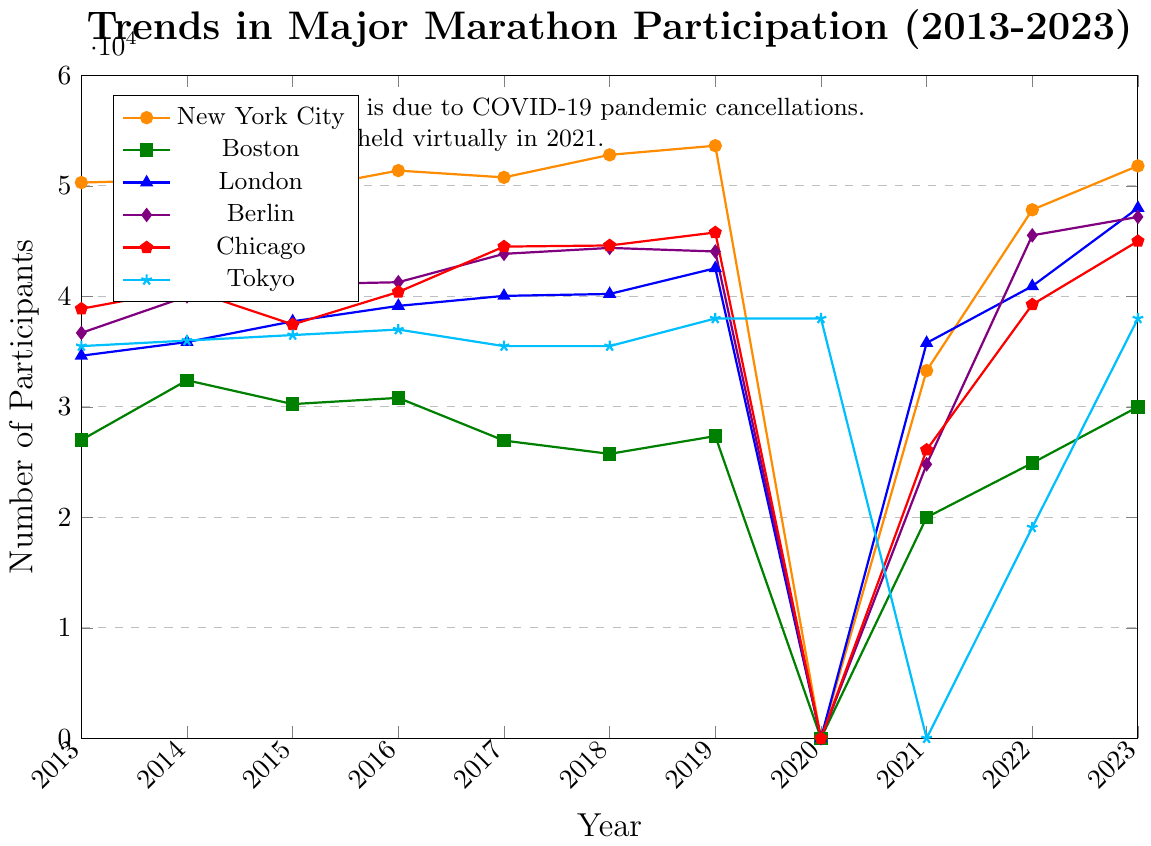what major marathon had the highest number of participants in 2023? The highest point in 2023 is marked with a triangle, corresponding to the London Marathon line, which indicates 48000 participants.
Answer: London Marathon Which marathon saw the largest drop in participation between 2019 and 2021? Compare the differences for each marathon between 2019 and 2021. Boston Marathon had the largest drop from 27355 to 20000, a decline of 7355 participants.
Answer: Boston Marathon What was the average participation in the New York City Marathon from 2013 to 2019? Calculate the mean of the participation numbers for the New York City Marathon from 2013 to 2019: (50304 + 50564 + 49595 + 51388 + 50773 + 52813 + 53640) / 7, which equals 51282.43.
Answer: 51282.43 Which marathon had the lowest number of participants in 2022? The lowest point in 2022 is marked with an asterisk/star, corresponding to the Tokyo Marathon line, which indicates 19088 participants.
Answer: Tokyo Marathon Between which two consecutive years did the Berlin Marathon experience the most significant increase in participants? Examine the year-to-year differences in Berlin Marathon participation. The most significant increase is from 2021 (24796) to 2022 (45527), with an increase of 20731 participants.
Answer: 2021 to 2022 Did the Tokyo Marathon have any years without data, and if so, which years? Observing the Tokyo Marathon line, there is no data point in 2021.
Answer: 2021 What is the sum of participants for the Chicago Marathon in the years it had over 44000 participants? The Chicago Marathon had over 44000 participants in 2017 (44508), 2018 (44610), 2019 (45786), and 2023 (45000). Summing these gives 44508 + 44610 + 45786 + 45000 = 179904.
Answer: 179904 Was there any marathon that didn't experience a significant drop in participants in 2020 due to the pandemic? All marathons in 2020 have data points showing zero participants due to the pandemic, except Tokyo, which held a virtual marathon.
Answer: Tokyo Marathon How did the participation trend for the Boston Marathon from 2013 to 2023 compare to the New York City Marathon? The Boston Marathon shows a decline from 2013 to 2019, a sharp drop in 2020, and a gradual recovery. In contrast, the New York City Marathon shows an overall increasing trend from 2013 to 2019 with a drop in 2020 and recovery.
Answer: The Boston Marathon declined then partially recovered, while the New York City Marathon generally increased then recovered 